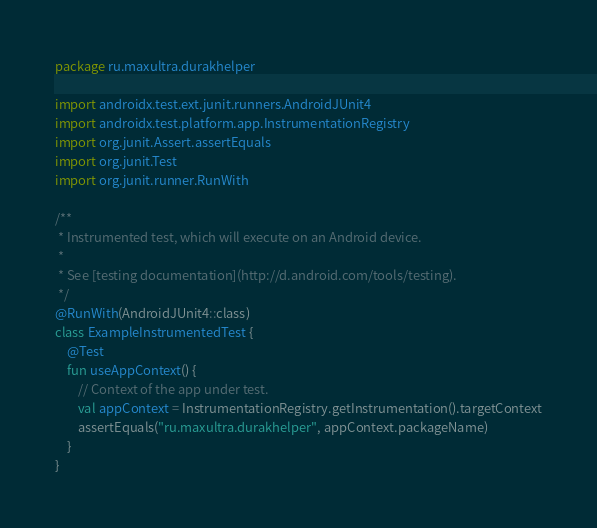<code> <loc_0><loc_0><loc_500><loc_500><_Kotlin_>package ru.maxultra.durakhelper

import androidx.test.ext.junit.runners.AndroidJUnit4
import androidx.test.platform.app.InstrumentationRegistry
import org.junit.Assert.assertEquals
import org.junit.Test
import org.junit.runner.RunWith

/**
 * Instrumented test, which will execute on an Android device.
 *
 * See [testing documentation](http://d.android.com/tools/testing).
 */
@RunWith(AndroidJUnit4::class)
class ExampleInstrumentedTest {
    @Test
    fun useAppContext() {
        // Context of the app under test.
        val appContext = InstrumentationRegistry.getInstrumentation().targetContext
        assertEquals("ru.maxultra.durakhelper", appContext.packageName)
    }
}
</code> 